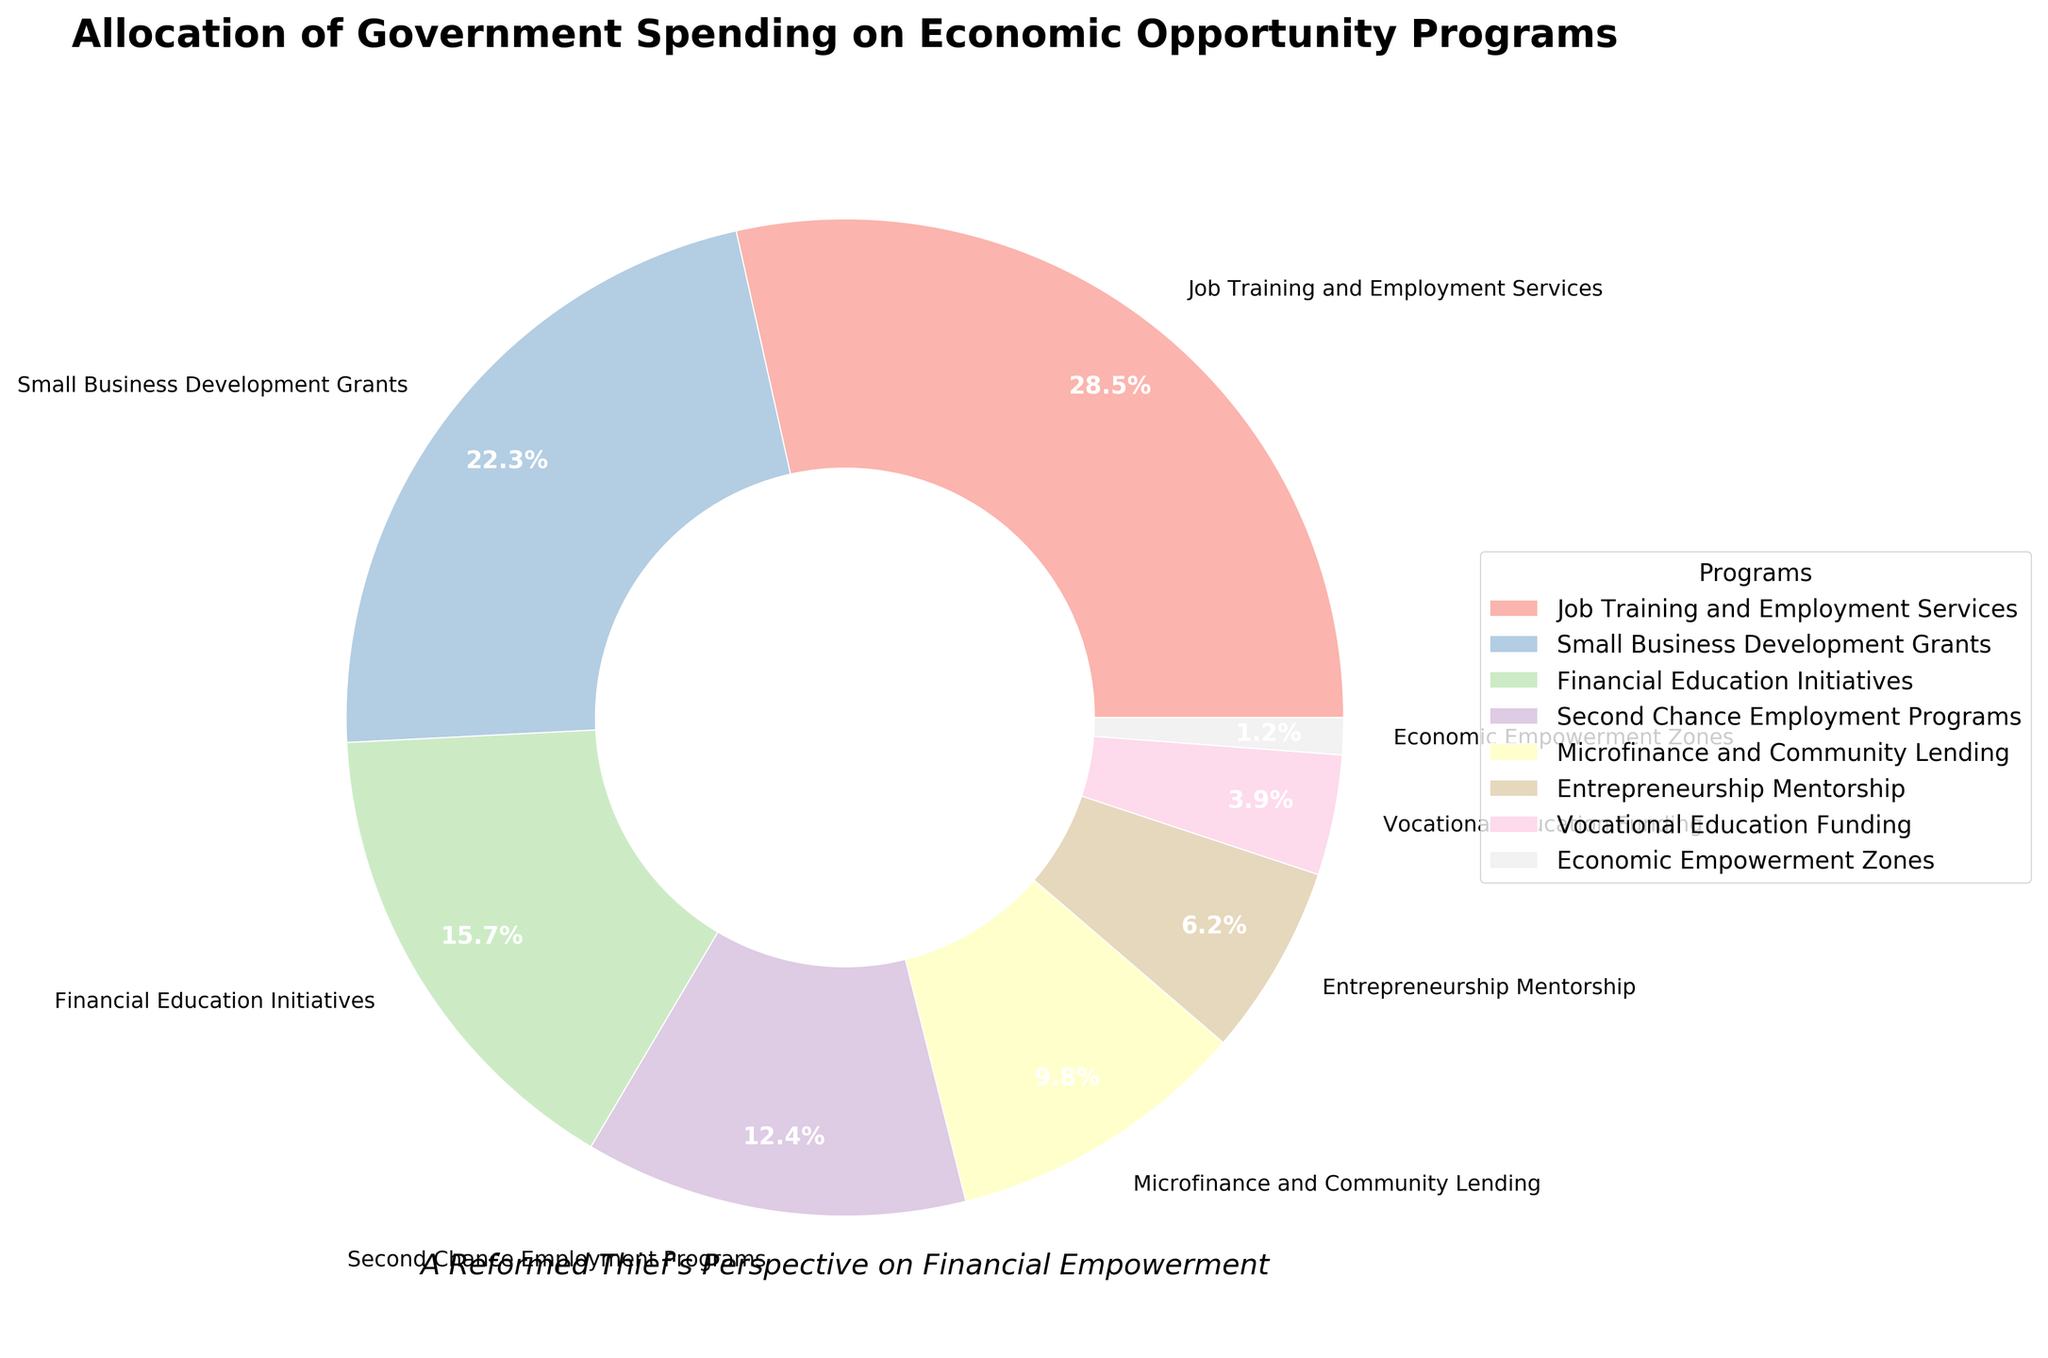What's the largest allocation of government spending among the programs? Identify the largest percentage value from the chart, which corresponds to Job Training and Employment Services at 28.5%.
Answer: Job Training and Employment Services Which program receives the least funding? Identify the smallest percentage, which corresponds to Economic Empowerment Zones at 1.2%.
Answer: Economic Empowerment Zones What is the total percentage of spending allocated to programs aimed explicitly at employment (Job Training, Second Chance Employment)? Add the percentages of Job Training and Employment Services (28.5%) and Second Chance Employment Programs (12.4%), giving a total of 40.9%.
Answer: 40.9% Which two programs combined receive almost the same percentage of funding as Job Training and Employment Services alone? Look for two programs whose combined percentage approximates that of Job Training and Employment Services (28.5%). Small Business Development Grants (22.3%) + Economic Empowerment Zones (6.2%) = 28.5%.
Answer: Small Business Development Grants and Economic Empowerment Zones Is the funding for Financial Education Initiatives greater than for Second Chance Employment Programs? Compare the percentage for Financial Education Initiatives (15.7%) with Second Chance Employment Programs (12.4%). Since 15.7% > 12.4%, the answer is yes.
Answer: Yes Combine the funding percentages of Financial Education Initiatives, Vocational Education Funding, and Entrepreneurship Mentorship programs. What's the total? Add the percentages of Financial Education Initiatives (15.7%), Vocational Education Funding (3.9%), and Entrepreneurship Mentorship (6.2%), giving 25.8%.
Answer: 25.8% Which programs have funding percentages that are below 10%? Identify the programs with percentages less than 10%: Microfinance and Community Lending (9.8%), Entrepreneurship Mentorship (6.2%), Vocational Education Funding (3.9%), and Economic Empowerment Zones (1.2%).
Answer: Microfinance and Community Lending, Entrepreneurship Mentorship, Vocational Education Funding, Economic Empowerment Zones How does the funding for Microfinance and Community Lending compare to that for Small Business Development Grants? Compare the percentages: Microfinance and Community Lending has 9.8%, while Small Business Development Grants has 22.3%, making it clear that Small Business Development Grants receive more funding.
Answer: Small Business Development Grants receive more funding What's the combined funding percentage for all programs categorized under education (Financial Education Initiatives and Vocational Education Funding)? Add the percentages of Financial Education Initiatives (15.7%) and Vocational Education Funding (3.9%), giving 19.6%.
Answer: 19.6% Which programs' allocations are greater than Microfinance and Community Lending's 9.8%? Identify the programs with percentages greater than 9.8%. These are Job Training and Employment Services (28.5%), Small Business Development Grants (22.3%), and Financial Education Initiatives (15.7%), and Second Chance Employment Programs (12.4%).
Answer: Job Training and Employment Services, Small Business Development Grants, Financial Education Initiatives, Second Chance Employment Programs 